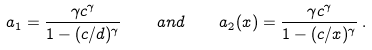<formula> <loc_0><loc_0><loc_500><loc_500>a _ { 1 } = \frac { \gamma c ^ { \gamma } } { 1 - ( c / d ) ^ { \gamma } } \quad a n d \quad a _ { 2 } ( x ) = \frac { \gamma c ^ { \gamma } } { 1 - ( c / x ) ^ { \gamma } } \, .</formula> 